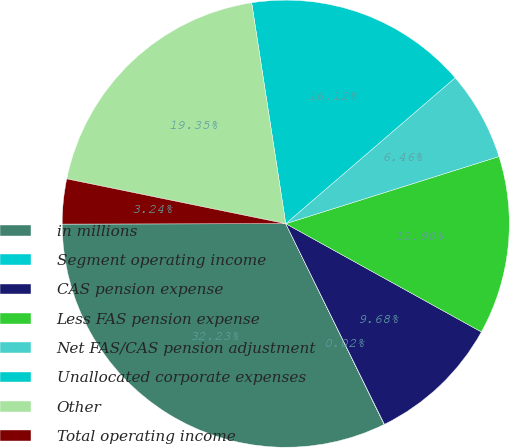Convert chart to OTSL. <chart><loc_0><loc_0><loc_500><loc_500><pie_chart><fcel>in millions<fcel>Segment operating income<fcel>CAS pension expense<fcel>Less FAS pension expense<fcel>Net FAS/CAS pension adjustment<fcel>Unallocated corporate expenses<fcel>Other<fcel>Total operating income<nl><fcel>32.23%<fcel>0.02%<fcel>9.68%<fcel>12.9%<fcel>6.46%<fcel>16.12%<fcel>19.35%<fcel>3.24%<nl></chart> 